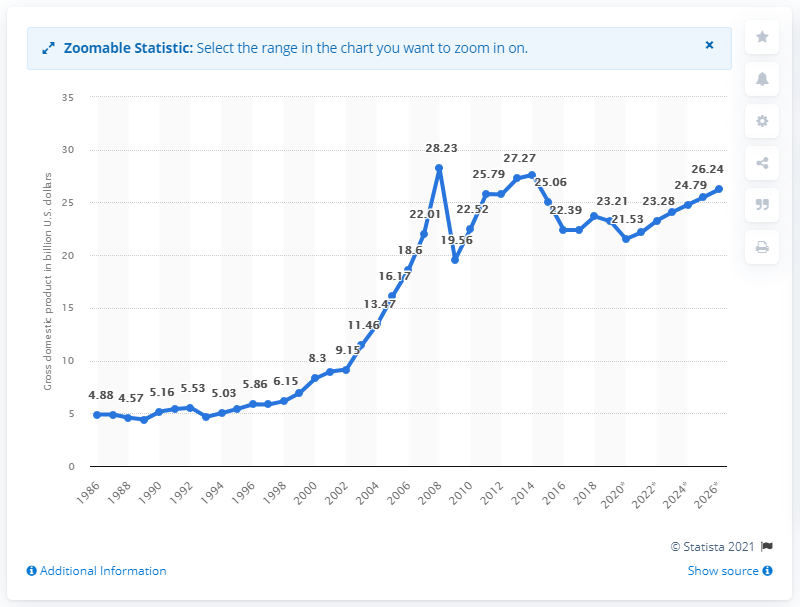List a handful of essential elements in this visual. In 2019, Trinidad and Tobago's Gross Domestic Product was 23.28 billion. 